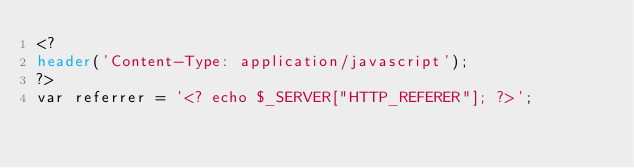<code> <loc_0><loc_0><loc_500><loc_500><_PHP_><?
header('Content-Type: application/javascript');
?>
var referrer = '<? echo $_SERVER["HTTP_REFERER"]; ?>';</code> 